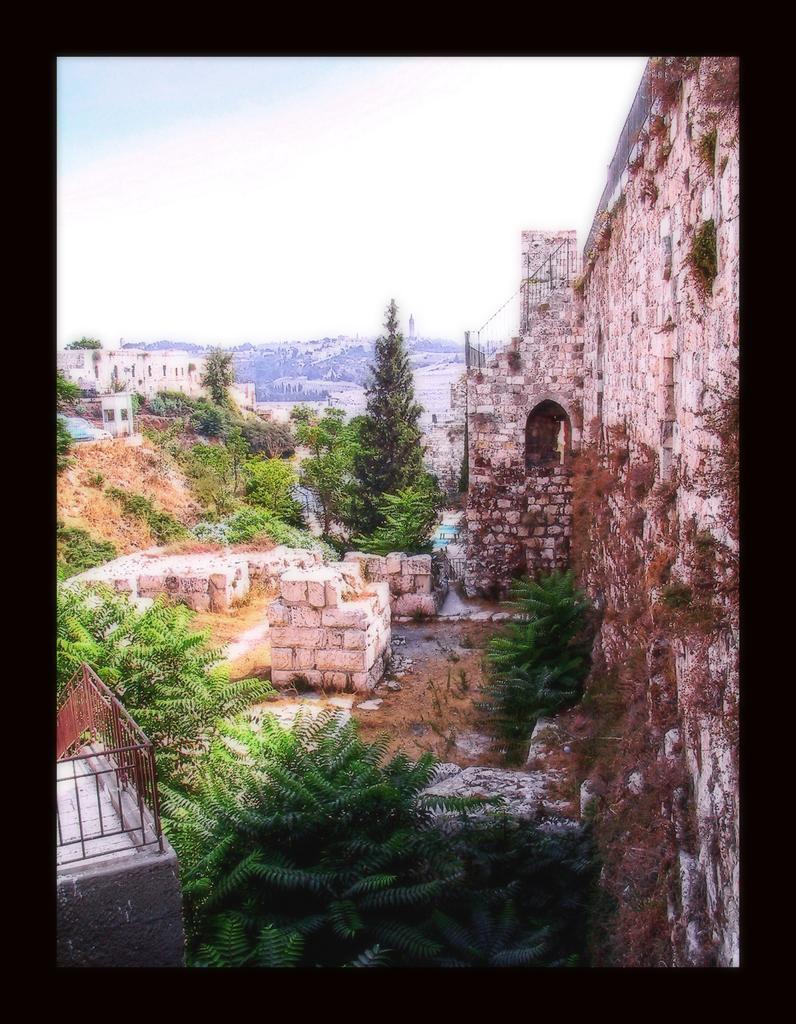How would you summarize this image in a sentence or two? In this image we can see trees, stone wall, buildings, hills and sky in the background. 